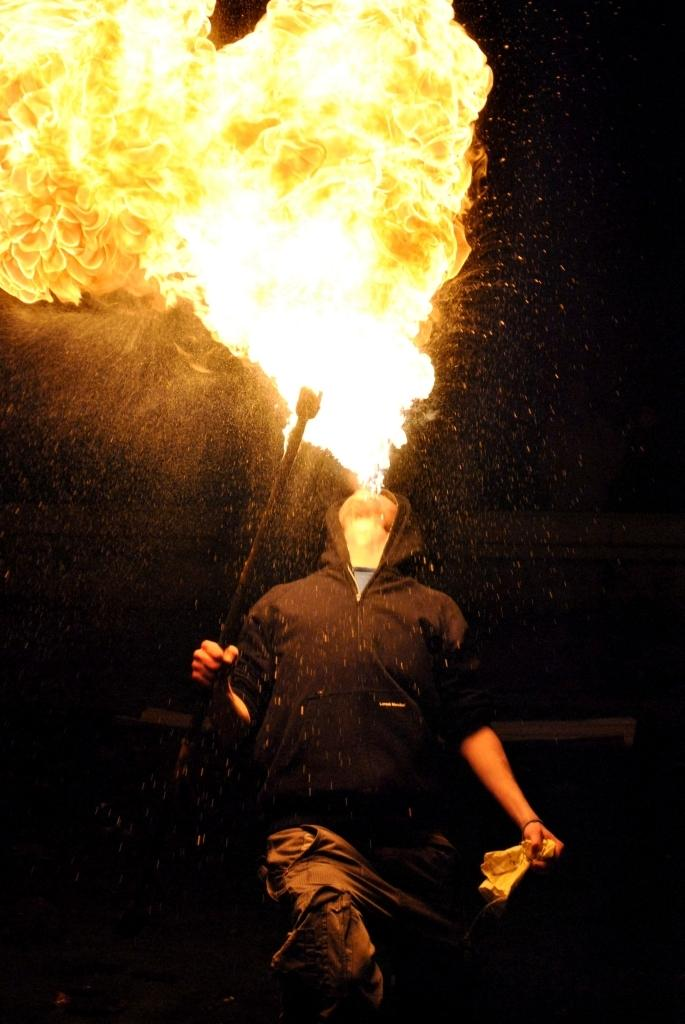What is the person holding in the image? The person is holding an object in the image. What is the person doing with the fire in the image? The person is blowing fire in the image. What can be observed about the lighting in the image? The background of the image is dark. How many planes can be seen flying in the image? There are no planes visible in the image. Is there a doll present in the image? There is no doll present in the image. 